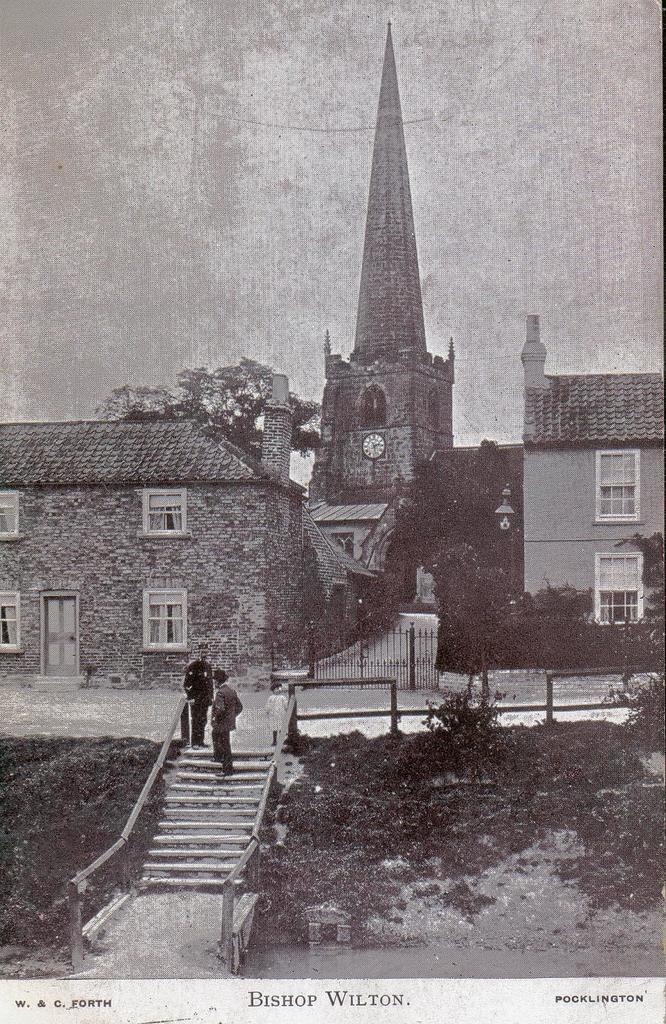What type of structures can be seen in the image? There are buildings in the image. Can you describe a specific architectural feature in the image? There is a staircase in the image. Are there any people present in the image? Yes, there are people on the staircase. What type of vegetation can be seen in the image? There are trees and plants in the image. How many children are riding on the back of the giraffe in the image? There is no giraffe present in the image, and therefore no children riding on its back. What tool is being used to hammer nails into the building in the image? There is no hammer or nail-related activity depicted in the image. 